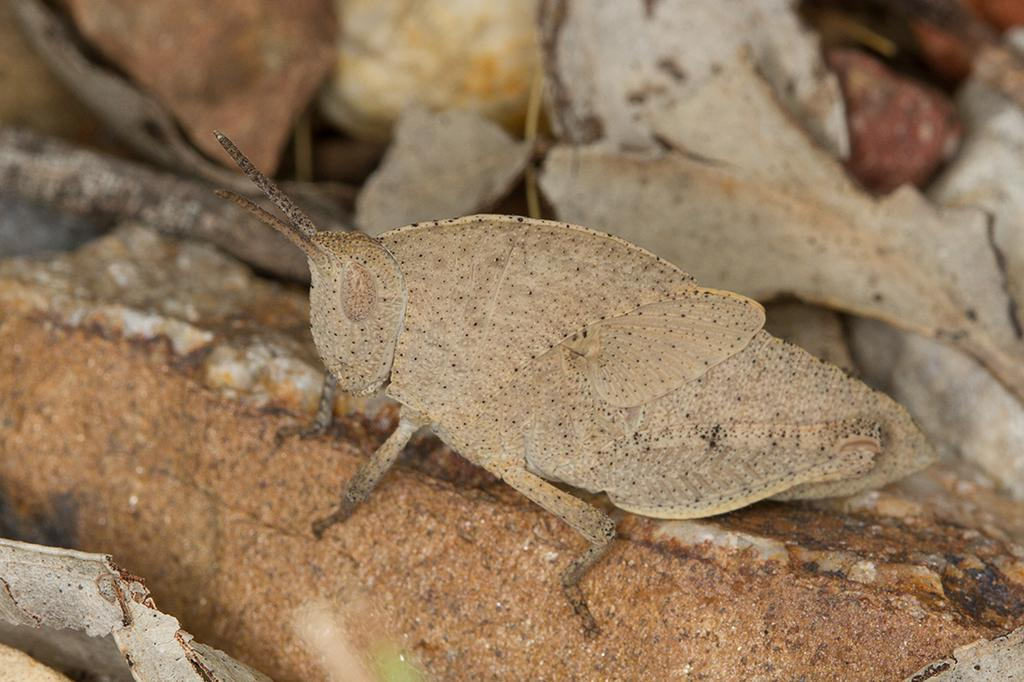What type of natural material can be seen in the image? There are dried leaves in the image. What living creature is present in the image? There is a moth in the image. What is the color of the surface in the image? The surface in the image is brown. What type of mineral can be seen in the image? There is no mineral present in the image; it features dried leaves and a moth on a brown surface. What phase of the moon is visible in the image? There is no moon present in the image. 